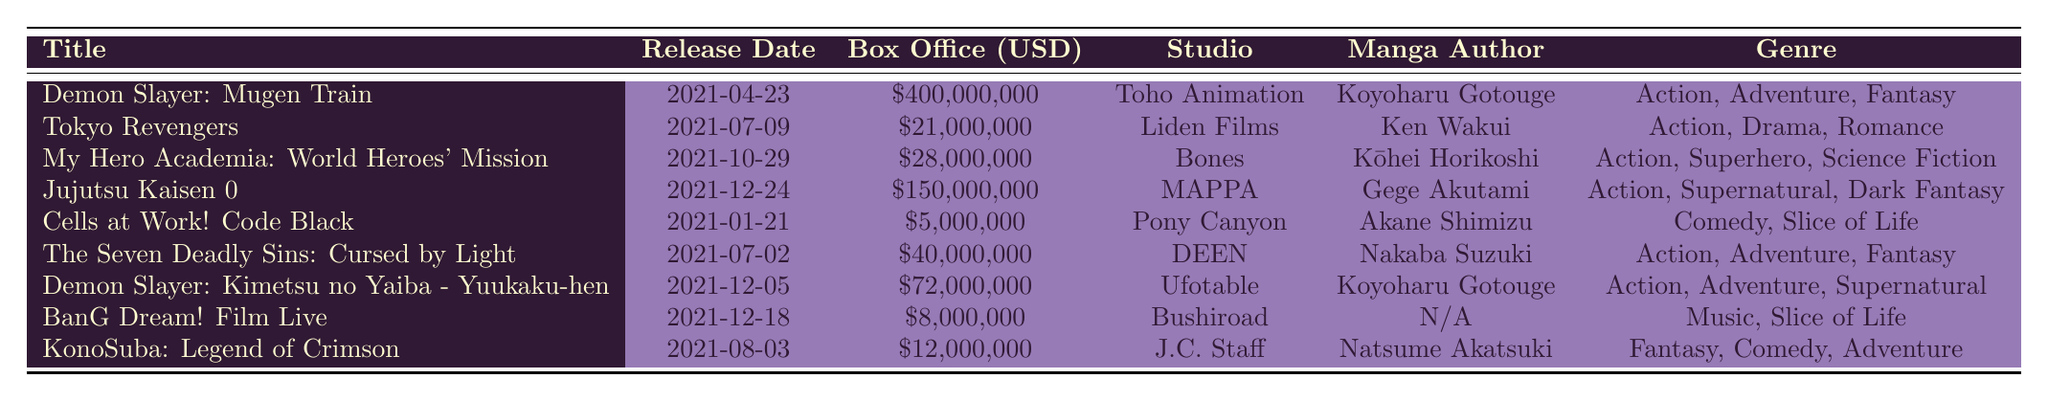What is the box office gross of "Demon Slayer: Mugen Train"? The table lists the box office gross for "Demon Slayer: Mugen Train" as $400,000,000.
Answer: $400,000,000 Which studio produced "Tokyo Revengers"? According to the table, "Tokyo Revengers" was produced by Liden Films.
Answer: Liden Films What genre does "Jujutsu Kaisen 0" belong to? The genre for "Jujutsu Kaisen 0" in the table is provided as Action, Supernatural, Dark Fantasy.
Answer: Action, Supernatural, Dark Fantasy How many movies grossed more than $70 million? The movies that grossed more than $70 million are "Demon Slayer: Mugen Train" ($400 million) and "Jujutsu Kaisen 0" ($150 million) and "Demon Slayer: Kimetsu no Yaiba - Yuukaku-hen" ($72 million), making a total of 3 movies.
Answer: 3 What is the average box office gross of all listed movies? The total box office gross is $400,000,000 + $21,000,000 + $28,000,000 + $150,000,000 + $5,000,000 + $40,000,000 + $72,000,000 + $8,000,000 + $12,000,000 = $728,000,000. There are 9 movies, so the average is $728,000,000 / 9 = $80,888,888.89.
Answer: $80,888,888.89 Is "Cells at Work! Code Black" an action movie? The table categorizes "Cells at Work! Code Black" under Comedy, Slice of Life, so it is not classified as an action movie.
Answer: No Which movie released first, "Demon Slayer: Kimetsu no Yaiba - Yuukaku-hen" or "Jujutsu Kaisen 0"? The release date for "Demon Slayer: Kimetsu no Yaiba - Yuukaku-hen" is 2021-12-05, and for "Jujutsu Kaisen 0" it is 2021-12-24. Thus, "Demon Slayer: Kimetsu no Yaiba - Yuukaku-hen" was released first.
Answer: "Demon Slayer: Kimetsu no Yaiba - Yuukaku-hen" What is the total box office gross of all movies released in July 2021? The movies released in July 2021 are "Tokyo Revengers" ($21,000,000), "The Seven Deadly Sins: Cursed by Light" ($40,000,000), and the total is $21,000,000 + $40,000,000 = $61,000,000.
Answer: $61,000,000 Which manga author wrote the most movies listed? "Koyoharu Gotouge" wrote two movies: "Demon Slayer: Mugen Train" and "Demon Slayer: Kimetsu no Yaiba - Yuukaku-hen," which is more than any other author.
Answer: Koyoharu Gotouge Did any movie gross less than $10 million? The table notes that "Cells at Work! Code Black" ($5,000,000) and "BanG Dream! Film Live" ($8,000,000) both grossed less than $10 million.
Answer: Yes 